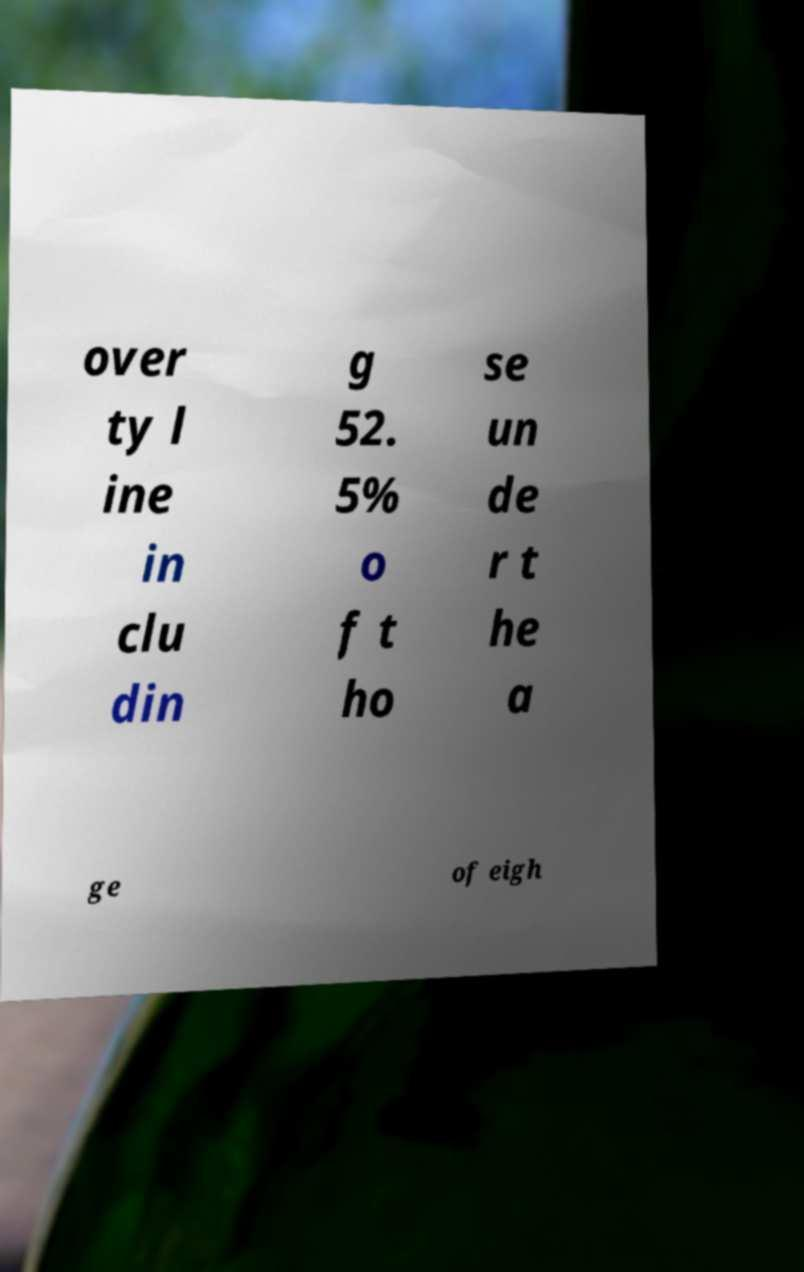Could you extract and type out the text from this image? over ty l ine in clu din g 52. 5% o f t ho se un de r t he a ge of eigh 